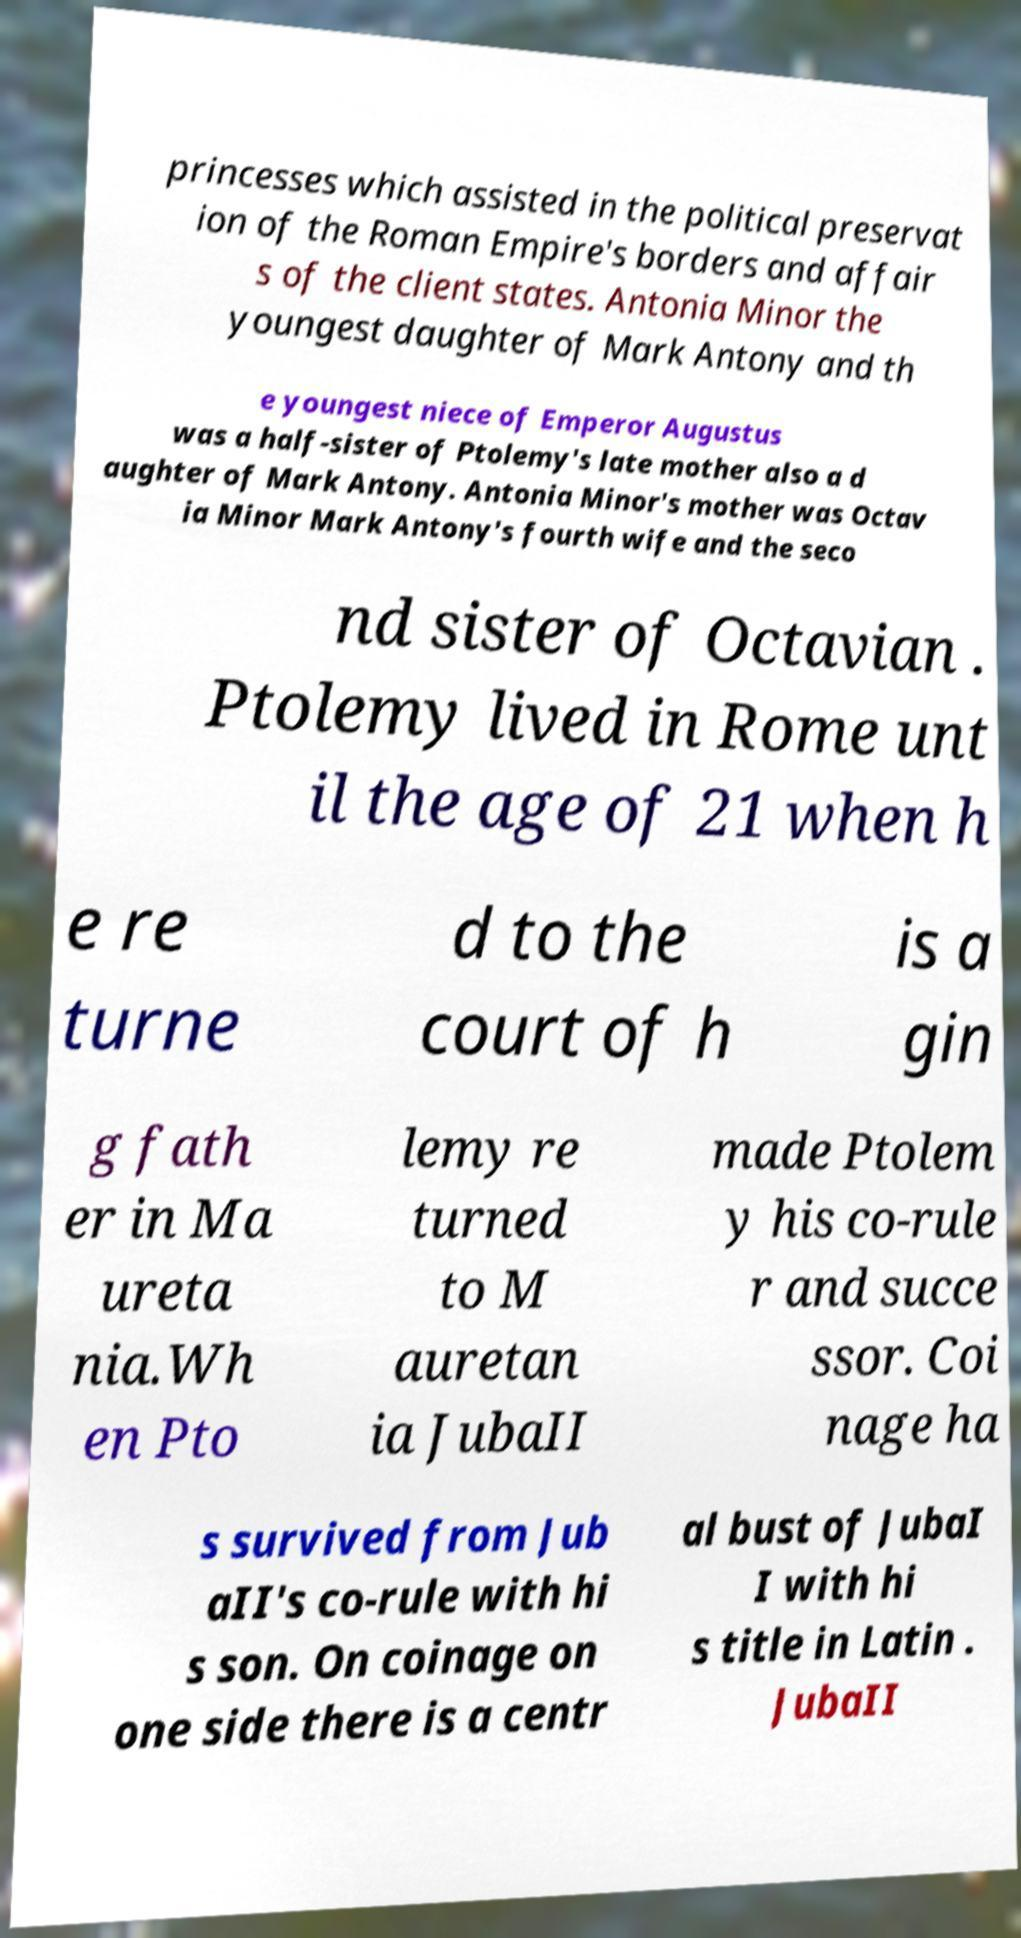For documentation purposes, I need the text within this image transcribed. Could you provide that? princesses which assisted in the political preservat ion of the Roman Empire's borders and affair s of the client states. Antonia Minor the youngest daughter of Mark Antony and th e youngest niece of Emperor Augustus was a half-sister of Ptolemy's late mother also a d aughter of Mark Antony. Antonia Minor's mother was Octav ia Minor Mark Antony's fourth wife and the seco nd sister of Octavian . Ptolemy lived in Rome unt il the age of 21 when h e re turne d to the court of h is a gin g fath er in Ma ureta nia.Wh en Pto lemy re turned to M auretan ia JubaII made Ptolem y his co-rule r and succe ssor. Coi nage ha s survived from Jub aII's co-rule with hi s son. On coinage on one side there is a centr al bust of JubaI I with hi s title in Latin . JubaII 